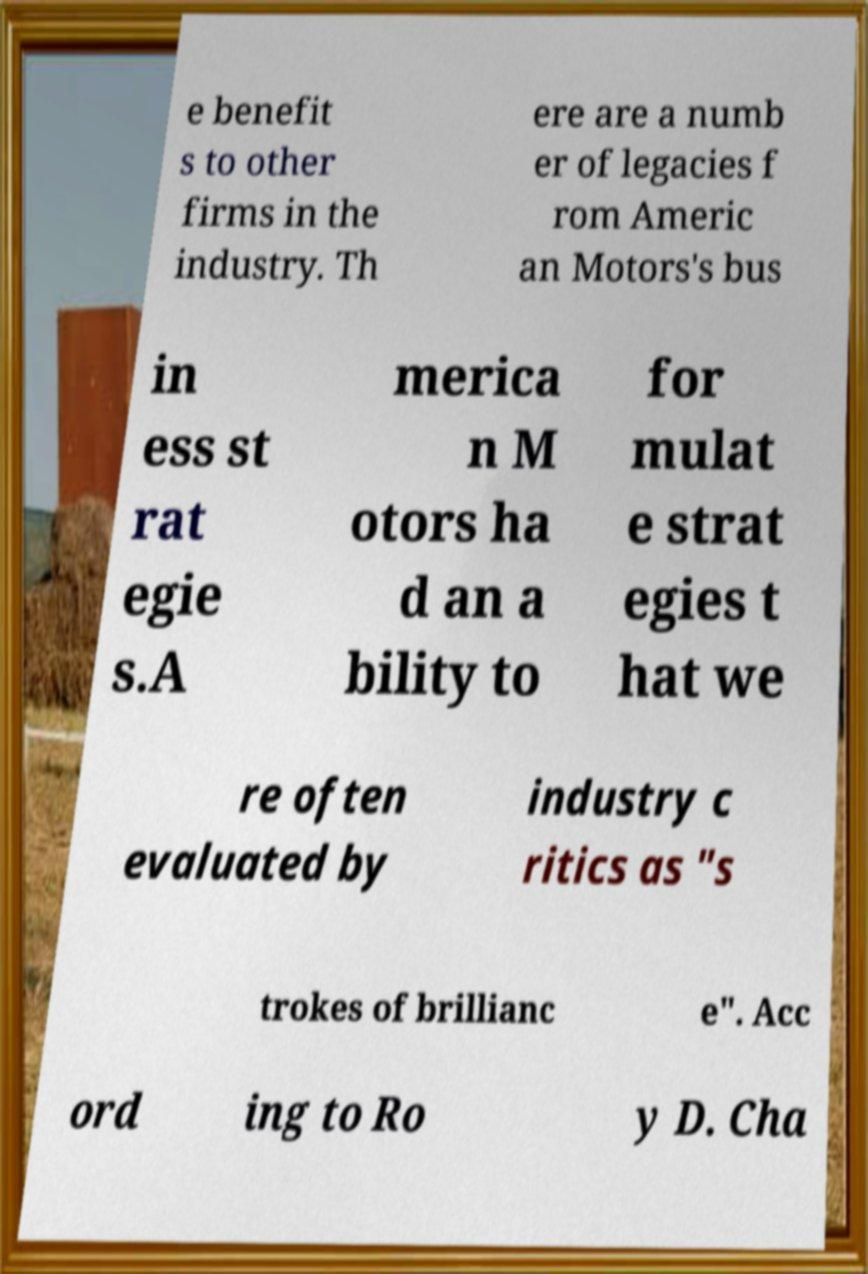Could you extract and type out the text from this image? e benefit s to other firms in the industry. Th ere are a numb er of legacies f rom Americ an Motors's bus in ess st rat egie s.A merica n M otors ha d an a bility to for mulat e strat egies t hat we re often evaluated by industry c ritics as "s trokes of brillianc e". Acc ord ing to Ro y D. Cha 